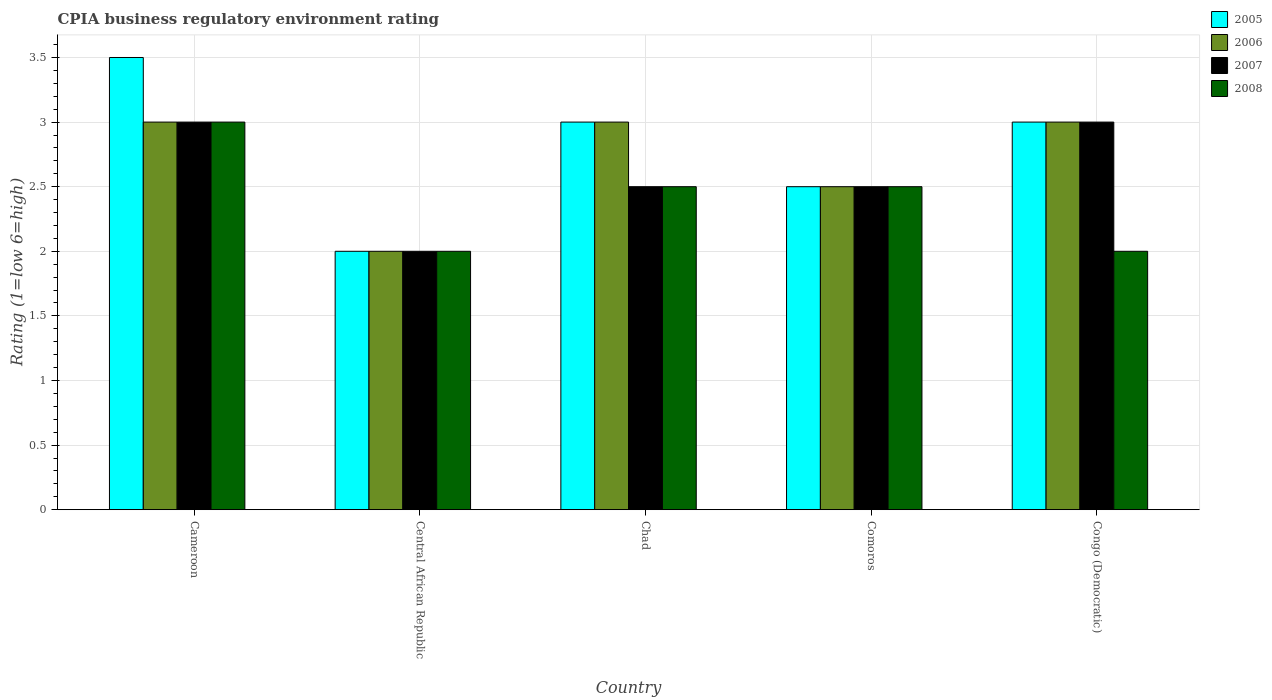Are the number of bars on each tick of the X-axis equal?
Your answer should be very brief. Yes. How many bars are there on the 5th tick from the left?
Your answer should be very brief. 4. How many bars are there on the 2nd tick from the right?
Make the answer very short. 4. What is the label of the 4th group of bars from the left?
Your answer should be very brief. Comoros. Across all countries, what is the minimum CPIA rating in 2005?
Your answer should be compact. 2. In which country was the CPIA rating in 2007 maximum?
Offer a very short reply. Cameroon. In which country was the CPIA rating in 2006 minimum?
Keep it short and to the point. Central African Republic. What is the difference between the CPIA rating in 2005 in Central African Republic and that in Comoros?
Give a very brief answer. -0.5. What is the ratio of the CPIA rating in 2007 in Cameroon to that in Central African Republic?
Your answer should be very brief. 1.5. Is the CPIA rating in 2006 in Cameroon less than that in Comoros?
Give a very brief answer. No. What does the 4th bar from the left in Central African Republic represents?
Offer a very short reply. 2008. What does the 4th bar from the right in Chad represents?
Make the answer very short. 2005. How many bars are there?
Your answer should be very brief. 20. Are all the bars in the graph horizontal?
Provide a succinct answer. No. What is the difference between two consecutive major ticks on the Y-axis?
Provide a short and direct response. 0.5. Are the values on the major ticks of Y-axis written in scientific E-notation?
Your answer should be very brief. No. Does the graph contain any zero values?
Provide a succinct answer. No. How are the legend labels stacked?
Provide a short and direct response. Vertical. What is the title of the graph?
Provide a short and direct response. CPIA business regulatory environment rating. What is the label or title of the Y-axis?
Ensure brevity in your answer.  Rating (1=low 6=high). What is the Rating (1=low 6=high) in 2005 in Cameroon?
Ensure brevity in your answer.  3.5. What is the Rating (1=low 6=high) of 2007 in Cameroon?
Keep it short and to the point. 3. What is the Rating (1=low 6=high) of 2008 in Cameroon?
Ensure brevity in your answer.  3. What is the Rating (1=low 6=high) of 2006 in Central African Republic?
Your answer should be compact. 2. What is the Rating (1=low 6=high) in 2006 in Chad?
Give a very brief answer. 3. What is the Rating (1=low 6=high) of 2005 in Comoros?
Your response must be concise. 2.5. What is the Rating (1=low 6=high) of 2006 in Comoros?
Your response must be concise. 2.5. What is the Rating (1=low 6=high) in 2007 in Comoros?
Provide a succinct answer. 2.5. What is the Rating (1=low 6=high) in 2006 in Congo (Democratic)?
Your response must be concise. 3. What is the Rating (1=low 6=high) of 2008 in Congo (Democratic)?
Provide a short and direct response. 2. Across all countries, what is the maximum Rating (1=low 6=high) in 2005?
Provide a short and direct response. 3.5. Across all countries, what is the maximum Rating (1=low 6=high) of 2006?
Your response must be concise. 3. Across all countries, what is the minimum Rating (1=low 6=high) in 2005?
Offer a terse response. 2. Across all countries, what is the minimum Rating (1=low 6=high) of 2007?
Offer a very short reply. 2. Across all countries, what is the minimum Rating (1=low 6=high) of 2008?
Give a very brief answer. 2. What is the total Rating (1=low 6=high) of 2006 in the graph?
Provide a short and direct response. 13.5. What is the total Rating (1=low 6=high) of 2007 in the graph?
Keep it short and to the point. 13. What is the total Rating (1=low 6=high) in 2008 in the graph?
Your answer should be very brief. 12. What is the difference between the Rating (1=low 6=high) of 2008 in Cameroon and that in Central African Republic?
Your response must be concise. 1. What is the difference between the Rating (1=low 6=high) in 2006 in Cameroon and that in Chad?
Offer a very short reply. 0. What is the difference between the Rating (1=low 6=high) in 2007 in Cameroon and that in Chad?
Your answer should be compact. 0.5. What is the difference between the Rating (1=low 6=high) in 2008 in Cameroon and that in Chad?
Offer a very short reply. 0.5. What is the difference between the Rating (1=low 6=high) in 2006 in Cameroon and that in Comoros?
Offer a terse response. 0.5. What is the difference between the Rating (1=low 6=high) in 2008 in Cameroon and that in Comoros?
Offer a very short reply. 0.5. What is the difference between the Rating (1=low 6=high) of 2005 in Cameroon and that in Congo (Democratic)?
Make the answer very short. 0.5. What is the difference between the Rating (1=low 6=high) of 2006 in Cameroon and that in Congo (Democratic)?
Offer a terse response. 0. What is the difference between the Rating (1=low 6=high) in 2007 in Cameroon and that in Congo (Democratic)?
Give a very brief answer. 0. What is the difference between the Rating (1=low 6=high) of 2008 in Cameroon and that in Congo (Democratic)?
Your answer should be very brief. 1. What is the difference between the Rating (1=low 6=high) in 2006 in Central African Republic and that in Chad?
Provide a succinct answer. -1. What is the difference between the Rating (1=low 6=high) of 2007 in Central African Republic and that in Chad?
Keep it short and to the point. -0.5. What is the difference between the Rating (1=low 6=high) in 2008 in Central African Republic and that in Chad?
Give a very brief answer. -0.5. What is the difference between the Rating (1=low 6=high) in 2005 in Central African Republic and that in Comoros?
Provide a short and direct response. -0.5. What is the difference between the Rating (1=low 6=high) of 2006 in Central African Republic and that in Comoros?
Provide a short and direct response. -0.5. What is the difference between the Rating (1=low 6=high) in 2007 in Central African Republic and that in Comoros?
Offer a very short reply. -0.5. What is the difference between the Rating (1=low 6=high) in 2005 in Central African Republic and that in Congo (Democratic)?
Your answer should be very brief. -1. What is the difference between the Rating (1=low 6=high) of 2006 in Central African Republic and that in Congo (Democratic)?
Keep it short and to the point. -1. What is the difference between the Rating (1=low 6=high) of 2008 in Central African Republic and that in Congo (Democratic)?
Keep it short and to the point. 0. What is the difference between the Rating (1=low 6=high) in 2007 in Chad and that in Comoros?
Ensure brevity in your answer.  0. What is the difference between the Rating (1=low 6=high) in 2008 in Chad and that in Comoros?
Offer a terse response. 0. What is the difference between the Rating (1=low 6=high) of 2005 in Comoros and that in Congo (Democratic)?
Offer a terse response. -0.5. What is the difference between the Rating (1=low 6=high) in 2006 in Comoros and that in Congo (Democratic)?
Make the answer very short. -0.5. What is the difference between the Rating (1=low 6=high) of 2007 in Comoros and that in Congo (Democratic)?
Provide a succinct answer. -0.5. What is the difference between the Rating (1=low 6=high) of 2005 in Cameroon and the Rating (1=low 6=high) of 2007 in Central African Republic?
Your answer should be very brief. 1.5. What is the difference between the Rating (1=low 6=high) of 2005 in Cameroon and the Rating (1=low 6=high) of 2006 in Chad?
Your answer should be very brief. 0.5. What is the difference between the Rating (1=low 6=high) in 2005 in Cameroon and the Rating (1=low 6=high) in 2007 in Chad?
Offer a very short reply. 1. What is the difference between the Rating (1=low 6=high) of 2005 in Cameroon and the Rating (1=low 6=high) of 2008 in Chad?
Provide a succinct answer. 1. What is the difference between the Rating (1=low 6=high) of 2006 in Cameroon and the Rating (1=low 6=high) of 2007 in Chad?
Give a very brief answer. 0.5. What is the difference between the Rating (1=low 6=high) in 2006 in Cameroon and the Rating (1=low 6=high) in 2008 in Chad?
Offer a very short reply. 0.5. What is the difference between the Rating (1=low 6=high) of 2007 in Cameroon and the Rating (1=low 6=high) of 2008 in Chad?
Provide a short and direct response. 0.5. What is the difference between the Rating (1=low 6=high) in 2005 in Cameroon and the Rating (1=low 6=high) in 2006 in Comoros?
Make the answer very short. 1. What is the difference between the Rating (1=low 6=high) in 2005 in Cameroon and the Rating (1=low 6=high) in 2007 in Comoros?
Make the answer very short. 1. What is the difference between the Rating (1=low 6=high) in 2005 in Cameroon and the Rating (1=low 6=high) in 2008 in Comoros?
Your answer should be very brief. 1. What is the difference between the Rating (1=low 6=high) of 2006 in Cameroon and the Rating (1=low 6=high) of 2008 in Comoros?
Offer a terse response. 0.5. What is the difference between the Rating (1=low 6=high) in 2005 in Cameroon and the Rating (1=low 6=high) in 2006 in Congo (Democratic)?
Ensure brevity in your answer.  0.5. What is the difference between the Rating (1=low 6=high) of 2007 in Cameroon and the Rating (1=low 6=high) of 2008 in Congo (Democratic)?
Provide a succinct answer. 1. What is the difference between the Rating (1=low 6=high) in 2007 in Central African Republic and the Rating (1=low 6=high) in 2008 in Chad?
Give a very brief answer. -0.5. What is the difference between the Rating (1=low 6=high) of 2005 in Central African Republic and the Rating (1=low 6=high) of 2008 in Comoros?
Provide a short and direct response. -0.5. What is the difference between the Rating (1=low 6=high) in 2007 in Central African Republic and the Rating (1=low 6=high) in 2008 in Comoros?
Your answer should be very brief. -0.5. What is the difference between the Rating (1=low 6=high) of 2005 in Central African Republic and the Rating (1=low 6=high) of 2008 in Congo (Democratic)?
Keep it short and to the point. 0. What is the difference between the Rating (1=low 6=high) in 2006 in Central African Republic and the Rating (1=low 6=high) in 2008 in Congo (Democratic)?
Your answer should be very brief. 0. What is the difference between the Rating (1=low 6=high) in 2007 in Central African Republic and the Rating (1=low 6=high) in 2008 in Congo (Democratic)?
Provide a short and direct response. 0. What is the difference between the Rating (1=low 6=high) in 2005 in Chad and the Rating (1=low 6=high) in 2008 in Comoros?
Make the answer very short. 0.5. What is the difference between the Rating (1=low 6=high) of 2005 in Chad and the Rating (1=low 6=high) of 2006 in Congo (Democratic)?
Provide a short and direct response. 0. What is the difference between the Rating (1=low 6=high) in 2006 in Chad and the Rating (1=low 6=high) in 2007 in Congo (Democratic)?
Make the answer very short. 0. What is the difference between the Rating (1=low 6=high) of 2006 in Chad and the Rating (1=low 6=high) of 2008 in Congo (Democratic)?
Make the answer very short. 1. What is the difference between the Rating (1=low 6=high) of 2007 in Chad and the Rating (1=low 6=high) of 2008 in Congo (Democratic)?
Keep it short and to the point. 0.5. What is the difference between the Rating (1=low 6=high) in 2005 in Comoros and the Rating (1=low 6=high) in 2007 in Congo (Democratic)?
Ensure brevity in your answer.  -0.5. What is the difference between the Rating (1=low 6=high) in 2006 in Comoros and the Rating (1=low 6=high) in 2008 in Congo (Democratic)?
Make the answer very short. 0.5. What is the average Rating (1=low 6=high) of 2008 per country?
Provide a short and direct response. 2.4. What is the difference between the Rating (1=low 6=high) of 2005 and Rating (1=low 6=high) of 2007 in Cameroon?
Ensure brevity in your answer.  0.5. What is the difference between the Rating (1=low 6=high) in 2005 and Rating (1=low 6=high) in 2007 in Central African Republic?
Your answer should be very brief. 0. What is the difference between the Rating (1=low 6=high) in 2005 and Rating (1=low 6=high) in 2008 in Central African Republic?
Offer a terse response. 0. What is the difference between the Rating (1=low 6=high) of 2006 and Rating (1=low 6=high) of 2008 in Central African Republic?
Ensure brevity in your answer.  0. What is the difference between the Rating (1=low 6=high) in 2006 and Rating (1=low 6=high) in 2008 in Chad?
Your response must be concise. 0.5. What is the difference between the Rating (1=low 6=high) in 2007 and Rating (1=low 6=high) in 2008 in Chad?
Offer a terse response. 0. What is the difference between the Rating (1=low 6=high) in 2005 and Rating (1=low 6=high) in 2007 in Comoros?
Ensure brevity in your answer.  0. What is the difference between the Rating (1=low 6=high) of 2005 and Rating (1=low 6=high) of 2008 in Comoros?
Your response must be concise. 0. What is the difference between the Rating (1=low 6=high) in 2007 and Rating (1=low 6=high) in 2008 in Comoros?
Ensure brevity in your answer.  0. What is the difference between the Rating (1=low 6=high) of 2005 and Rating (1=low 6=high) of 2008 in Congo (Democratic)?
Give a very brief answer. 1. What is the difference between the Rating (1=low 6=high) in 2007 and Rating (1=low 6=high) in 2008 in Congo (Democratic)?
Your response must be concise. 1. What is the ratio of the Rating (1=low 6=high) in 2006 in Cameroon to that in Central African Republic?
Provide a succinct answer. 1.5. What is the ratio of the Rating (1=low 6=high) in 2005 in Cameroon to that in Chad?
Offer a terse response. 1.17. What is the ratio of the Rating (1=low 6=high) in 2006 in Cameroon to that in Chad?
Make the answer very short. 1. What is the ratio of the Rating (1=low 6=high) of 2008 in Cameroon to that in Chad?
Make the answer very short. 1.2. What is the ratio of the Rating (1=low 6=high) in 2005 in Cameroon to that in Comoros?
Make the answer very short. 1.4. What is the ratio of the Rating (1=low 6=high) of 2007 in Cameroon to that in Comoros?
Your answer should be compact. 1.2. What is the ratio of the Rating (1=low 6=high) in 2008 in Cameroon to that in Comoros?
Offer a very short reply. 1.2. What is the ratio of the Rating (1=low 6=high) in 2006 in Cameroon to that in Congo (Democratic)?
Keep it short and to the point. 1. What is the ratio of the Rating (1=low 6=high) in 2006 in Central African Republic to that in Chad?
Make the answer very short. 0.67. What is the ratio of the Rating (1=low 6=high) of 2005 in Central African Republic to that in Comoros?
Your response must be concise. 0.8. What is the ratio of the Rating (1=low 6=high) in 2007 in Central African Republic to that in Comoros?
Provide a short and direct response. 0.8. What is the ratio of the Rating (1=low 6=high) of 2007 in Central African Republic to that in Congo (Democratic)?
Offer a terse response. 0.67. What is the ratio of the Rating (1=low 6=high) of 2008 in Central African Republic to that in Congo (Democratic)?
Provide a short and direct response. 1. What is the ratio of the Rating (1=low 6=high) of 2005 in Chad to that in Comoros?
Offer a terse response. 1.2. What is the ratio of the Rating (1=low 6=high) in 2006 in Chad to that in Congo (Democratic)?
Your response must be concise. 1. What is the ratio of the Rating (1=low 6=high) of 2008 in Chad to that in Congo (Democratic)?
Offer a terse response. 1.25. What is the ratio of the Rating (1=low 6=high) in 2005 in Comoros to that in Congo (Democratic)?
Offer a very short reply. 0.83. What is the ratio of the Rating (1=low 6=high) in 2006 in Comoros to that in Congo (Democratic)?
Keep it short and to the point. 0.83. What is the ratio of the Rating (1=low 6=high) of 2008 in Comoros to that in Congo (Democratic)?
Your response must be concise. 1.25. What is the difference between the highest and the second highest Rating (1=low 6=high) in 2005?
Provide a succinct answer. 0.5. What is the difference between the highest and the lowest Rating (1=low 6=high) of 2006?
Give a very brief answer. 1. What is the difference between the highest and the lowest Rating (1=low 6=high) in 2007?
Give a very brief answer. 1. 